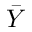Convert formula to latex. <formula><loc_0><loc_0><loc_500><loc_500>\bar { Y }</formula> 